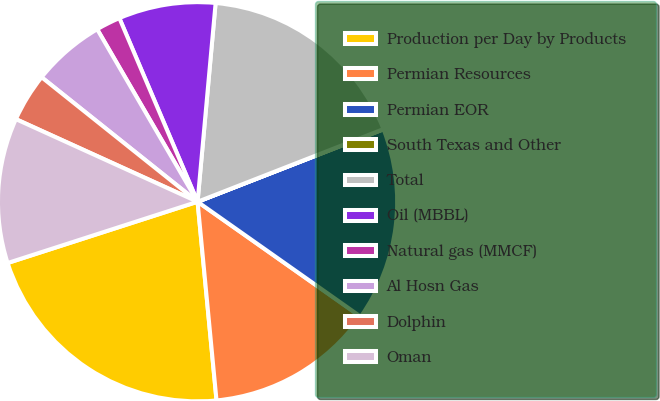Convert chart. <chart><loc_0><loc_0><loc_500><loc_500><pie_chart><fcel>Production per Day by Products<fcel>Permian Resources<fcel>Permian EOR<fcel>South Texas and Other<fcel>Total<fcel>Oil (MBBL)<fcel>Natural gas (MMCF)<fcel>Al Hosn Gas<fcel>Dolphin<fcel>Oman<nl><fcel>21.55%<fcel>13.72%<fcel>15.68%<fcel>0.02%<fcel>17.63%<fcel>7.85%<fcel>1.98%<fcel>5.89%<fcel>3.93%<fcel>11.76%<nl></chart> 